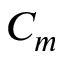<formula> <loc_0><loc_0><loc_500><loc_500>C _ { m }</formula> 